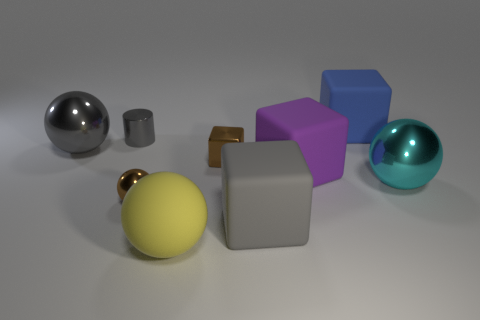Is the number of large purple rubber cubes less than the number of big matte objects?
Give a very brief answer. Yes. What is the big cube behind the big gray thing behind the tiny brown ball made of?
Your response must be concise. Rubber. Do the blue rubber cube and the shiny block have the same size?
Your response must be concise. No. How many things are cyan shiny things or shiny cylinders?
Your response must be concise. 2. What is the size of the rubber cube that is behind the cyan sphere and left of the blue block?
Your answer should be compact. Large. Are there fewer big cyan things behind the purple object than cyan rubber cubes?
Your response must be concise. No. What is the shape of the blue object that is made of the same material as the yellow thing?
Keep it short and to the point. Cube. There is a gray object right of the small shiny block; does it have the same shape as the small brown object right of the rubber ball?
Provide a succinct answer. Yes. Is the number of small gray objects to the right of the big purple rubber cube less than the number of blue things that are left of the large cyan metal ball?
Ensure brevity in your answer.  Yes. There is a large matte object that is the same color as the tiny cylinder; what shape is it?
Your response must be concise. Cube. 